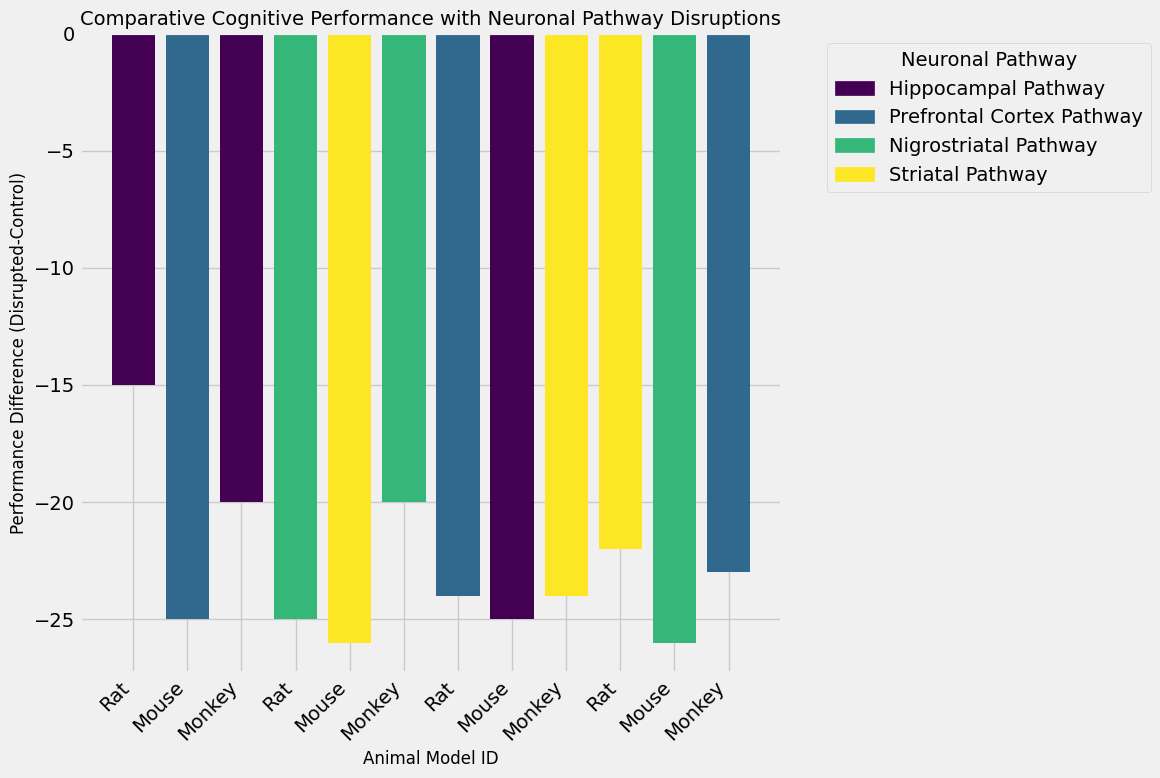Which animal model has the greatest cognitive performance decrease in the disrupted condition compared to the control? First, identify the bar with the lowest (most negative) performance difference. That bar corresponds to the animal model with the greatest decrease in performance.
Answer: Mouse (Prefrontal Cortex Pathway) Which neuronal pathway shows the least performance decrease across all animal models? Compare the height of the bars and find the pathway with the highest (least negative) performance difference among all.
Answer: Nigrostriatal Pathway How does the performance difference of the Hippocampal Pathway in rats compare to that in monkeys? Look at the bars corresponding to the Hippocampal Pathway in both rats and monkeys. Subtract the rat's performance difference from the monkey's performance difference.
Answer: The rats have a higher performance decrease than monkeys What is the average performance difference across all Mouse models? Identify the bars corresponding to Mouse models. Sum their performance differences and divide by the number of Mouse models.
Answer: (-25 + (-23) + (-25) + (-26)) / 4 = -24.75 What color represents the Prefrontal Cortex Pathway in the plot? Refer to the legend to determine the color associated with the Prefrontal Cortex Pathway.
Answer: The color representing Prefrontal Cortex Pathway is the one in the second position in the legend (as colored in the figure) Which neuronal pathway exhibits the highest performance decrease across all animal models? Identify the pathway associated with the most negative bar across the entire plot.
Answer: Prefrontal Cortex Pathway in Mouse Is there any pathway in which Monkey models perform better under disruption than the Rat models in terms of cognitive performance difference? Compare the performance differences in each pathway for Monkey and Rat models. Check if the performance difference is smaller (less negative or more positive) in Monkeys for any pathway.
Answer: Yes, in Hippocampal and Nigrostriatal pathways 